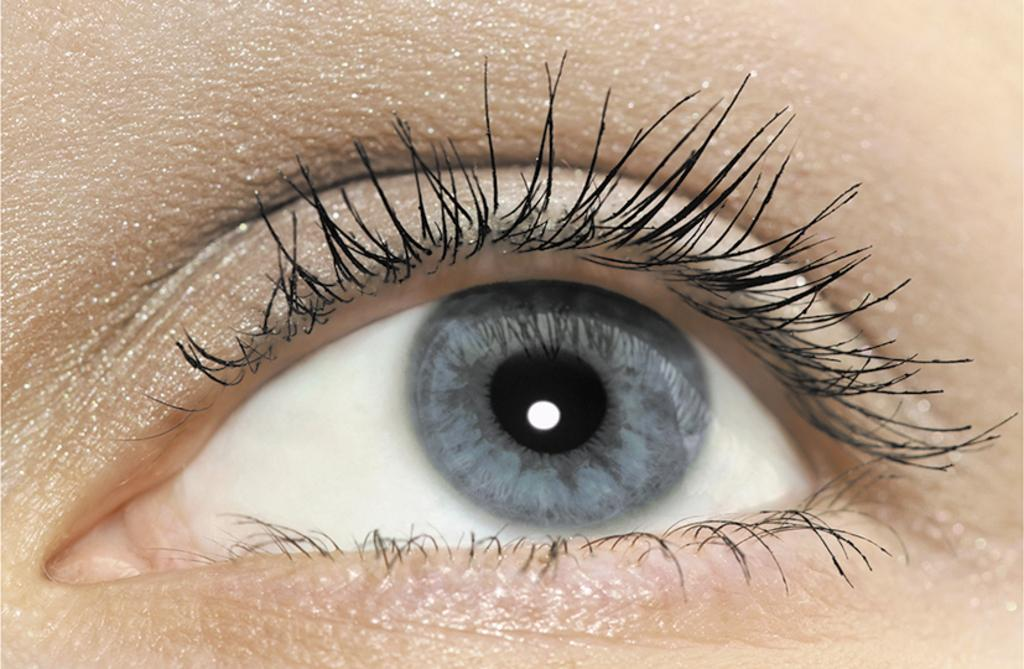What is the main subject of the image? The main subject of the image is a person's eye. What type of tax is being discussed in the image? There is no mention of any tax in the image, as it features a person's eye. 